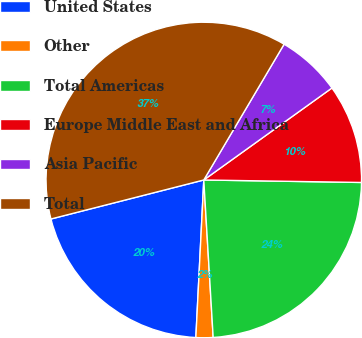Convert chart to OTSL. <chart><loc_0><loc_0><loc_500><loc_500><pie_chart><fcel>United States<fcel>Other<fcel>Total Americas<fcel>Europe Middle East and Africa<fcel>Asia Pacific<fcel>Total<nl><fcel>20.22%<fcel>1.75%<fcel>23.8%<fcel>10.16%<fcel>6.59%<fcel>37.48%<nl></chart> 